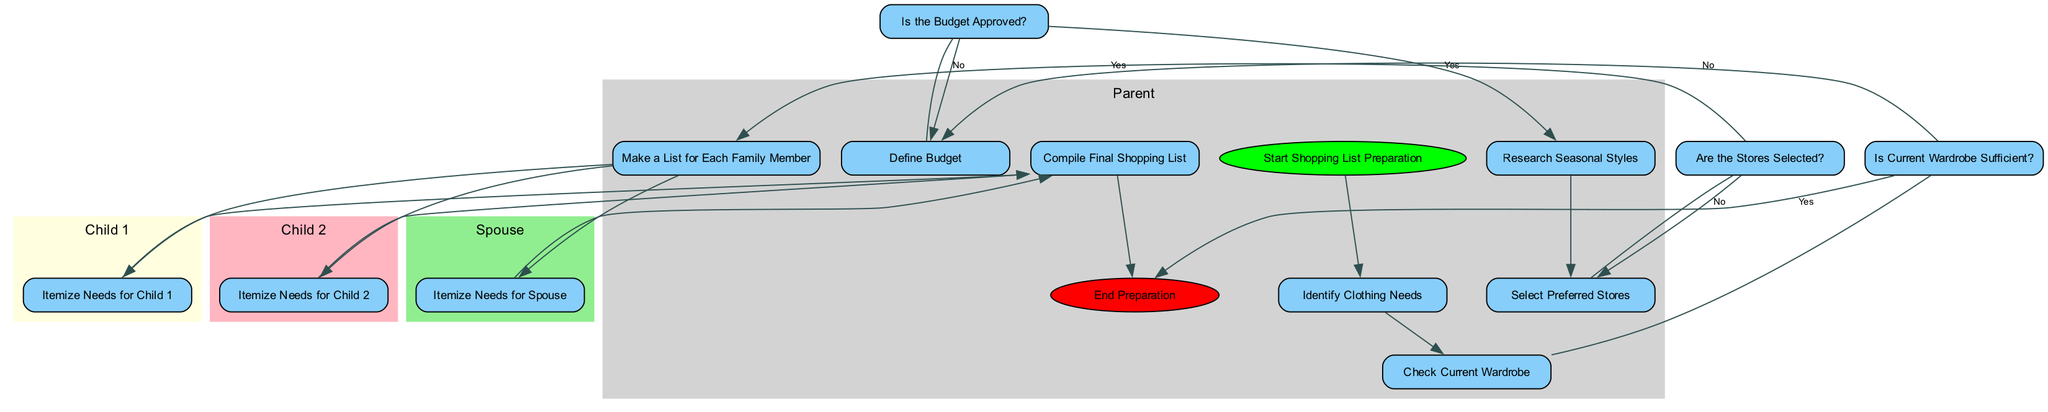What is the starting activity in the diagram? The starting activity is indicated by the "Start" node, which is labeled "Start Shopping List Preparation."
Answer: Start Shopping List Preparation What decision occurs after checking the current wardrobe? After checking the current wardrobe, the decision node labeled "Is Current Wardrobe Sufficient?" determines if the wardrobe is sufficient.
Answer: Is Current Wardrobe Sufficient? How many family members' needs are itemized in the list? There are four family members whose needs are itemized: Parent, Child 1, Child 2, and Spouse.
Answer: Four What happens if the budget is not approved? If the budget is not approved, the flow returns to the "Define Budget" activity to reassess the budget.
Answer: Define Budget Which activity follows the "Select Stores" activity in the diagram? The activity that follows "Select Stores" is "Make Family List," which indicates the preparation of individual lists for family members.
Answer: Make Family List What is the last activity in the diagram? The last activity in the diagram is indicated by the "End" node, which signifies the conclusion of the preparation process.
Answer: End How many total decisions are shown in the diagram? There are three decision nodes in the diagram: "Is Current Wardrobe Sufficient?", "Is the Budget Approved?", and "Are the Stores Selected?"
Answer: Three If the budget is approved, which activity follows next? If the budget is approved, the next activity is "Research Seasonal Styles," allowing for the exploration of various clothing options.
Answer: Research Seasonal Styles What type of diagram is represented by this illustration? This illustration represents an Activity Diagram, which showcases the various activities and decisions in a sequential flow for preparing a shopping list.
Answer: Activity Diagram 